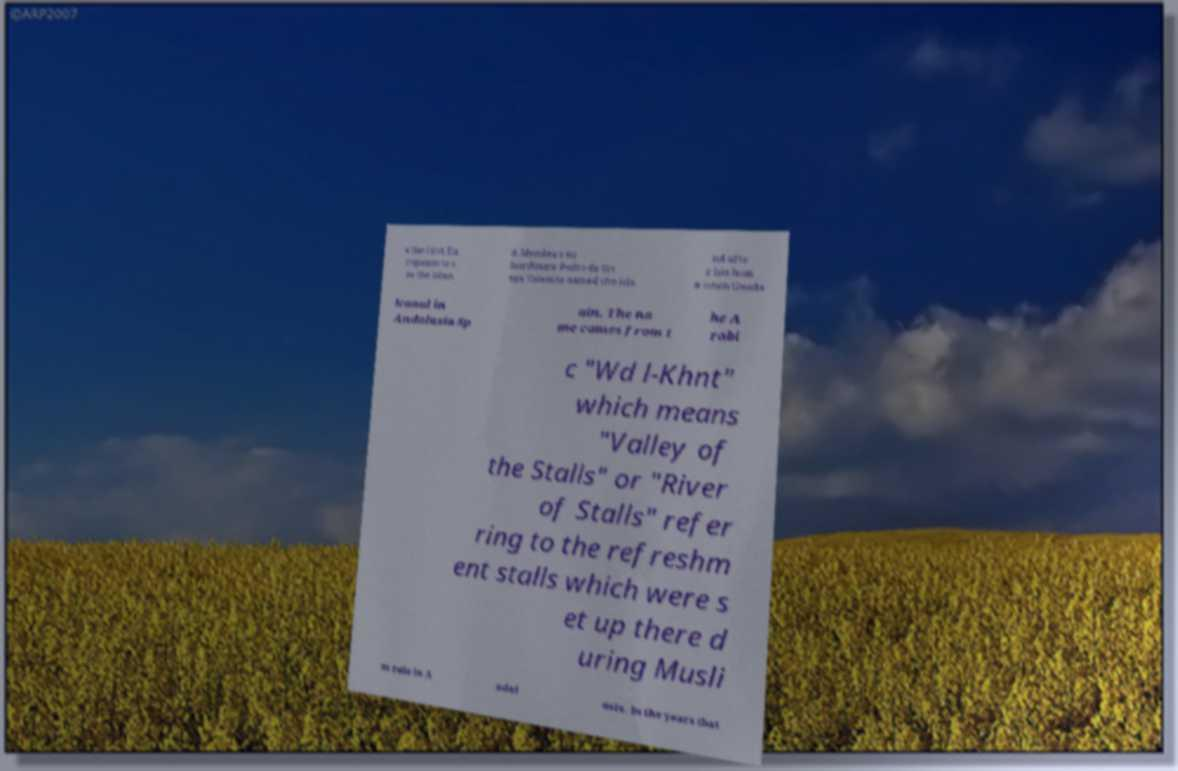I need the written content from this picture converted into text. Can you do that? e the first Eu ropeans to s ee the islan d. Mendaa's su bordinate Pedro de Ort ega Valencia named the isla nd afte r his hom e town Guada lcanal in Andalusia Sp ain. The na me comes from t he A rabi c "Wd l-Khnt" which means "Valley of the Stalls" or "River of Stalls" refer ring to the refreshm ent stalls which were s et up there d uring Musli m rule in A ndal usia. In the years that 